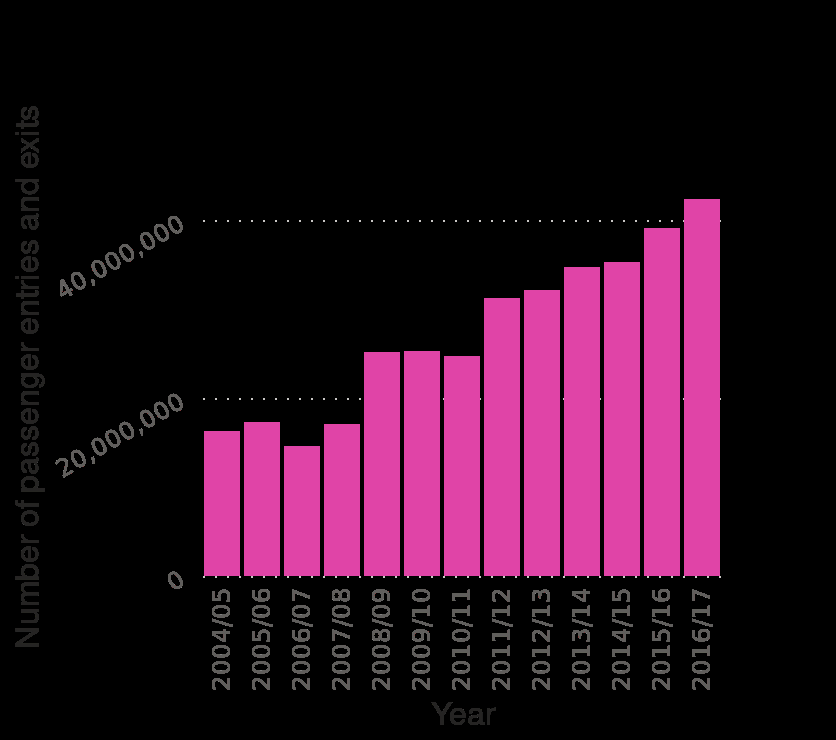<image>
Offer a thorough analysis of the image. The number of passengers entering and exiting Birmingham New Street has on average been rising steadily over time between 2004/05 to 2016/17. In 2016/17, there were over 40 million passengers enter and exit the station. 